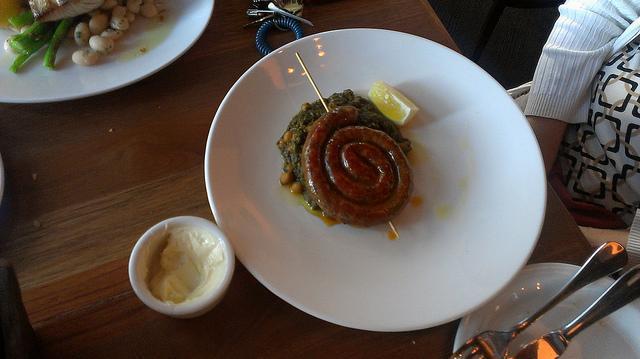How many utensils are visible?
Give a very brief answer. 2. How many forks are in the picture?
Give a very brief answer. 1. How many knives can you see?
Give a very brief answer. 1. How many of the chairs are blue?
Give a very brief answer. 0. 